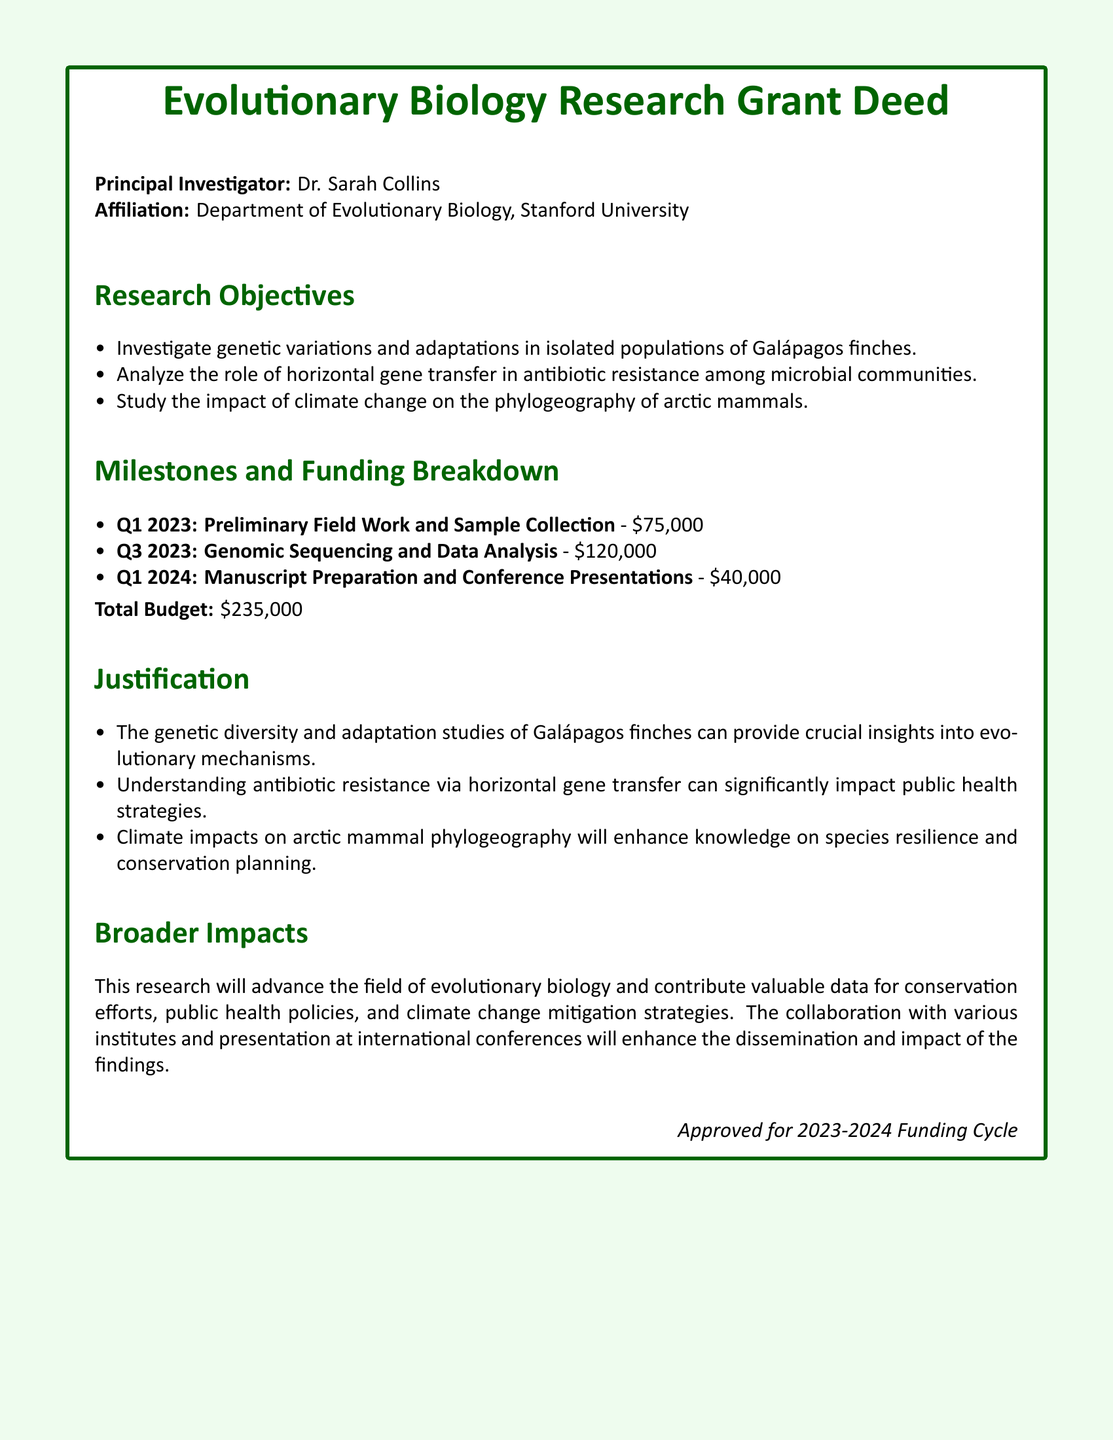What is the name of the Principal Investigator? The Principal Investigator is the individual responsible for leading the research project, and according to the document, this is Dr. Sarah Collins.
Answer: Dr. Sarah Collins What is the total budget for the research grant? The total budget is stated at the end of the funding breakdown section, which sums the amounts for all milestones to be \$235,000.
Answer: \$235,000 What is the first milestone for the research project? The first milestone is noted in the milestones section, which lists preliminary field work and sample collection.
Answer: Preliminary Field Work and Sample Collection How much funding is allocated for genomic sequencing and data analysis? The funding breakdown details that \$120,000 is allocated for genomic sequencing and data analysis during Q3 2023.
Answer: \$120,000 What is one research objective? The document lists several research objectives, including studying genetic variations in isolated populations of Galápagos finches as one of them.
Answer: Investigate genetic variations and adaptations in isolated populations of Galápagos finches What quarter is associated with manuscript preparation and conference presentations? The funding breakdown provides milestones linked to specific quarters, indicating that manuscript preparation and conference presentations are scheduled for Q1 2024.
Answer: Q1 2024 What is one of the broader impacts of the research? The document mentions that the research will advance the field of evolutionary biology as one of its broader impacts.
Answer: Advance the field of evolutionary biology How much funding is requested for the second milestone? The funding breakdown specifies the amount needed for the second milestone directly, which is \$120,000 for genomic sequencing and data analysis.
Answer: \$120,000 What role does horizontal gene transfer play in this research? The document addresses this in the research objectives, highlighting the investigation of its role in antibiotic resistance among microbial communities.
Answer: Role of horizontal gene transfer in antibiotic resistance What affiliation is listed for the Principal Investigator? The document states that Dr. Sarah Collins is affiliated with the Department of Evolutionary Biology at Stanford University.
Answer: Department of Evolutionary Biology, Stanford University 